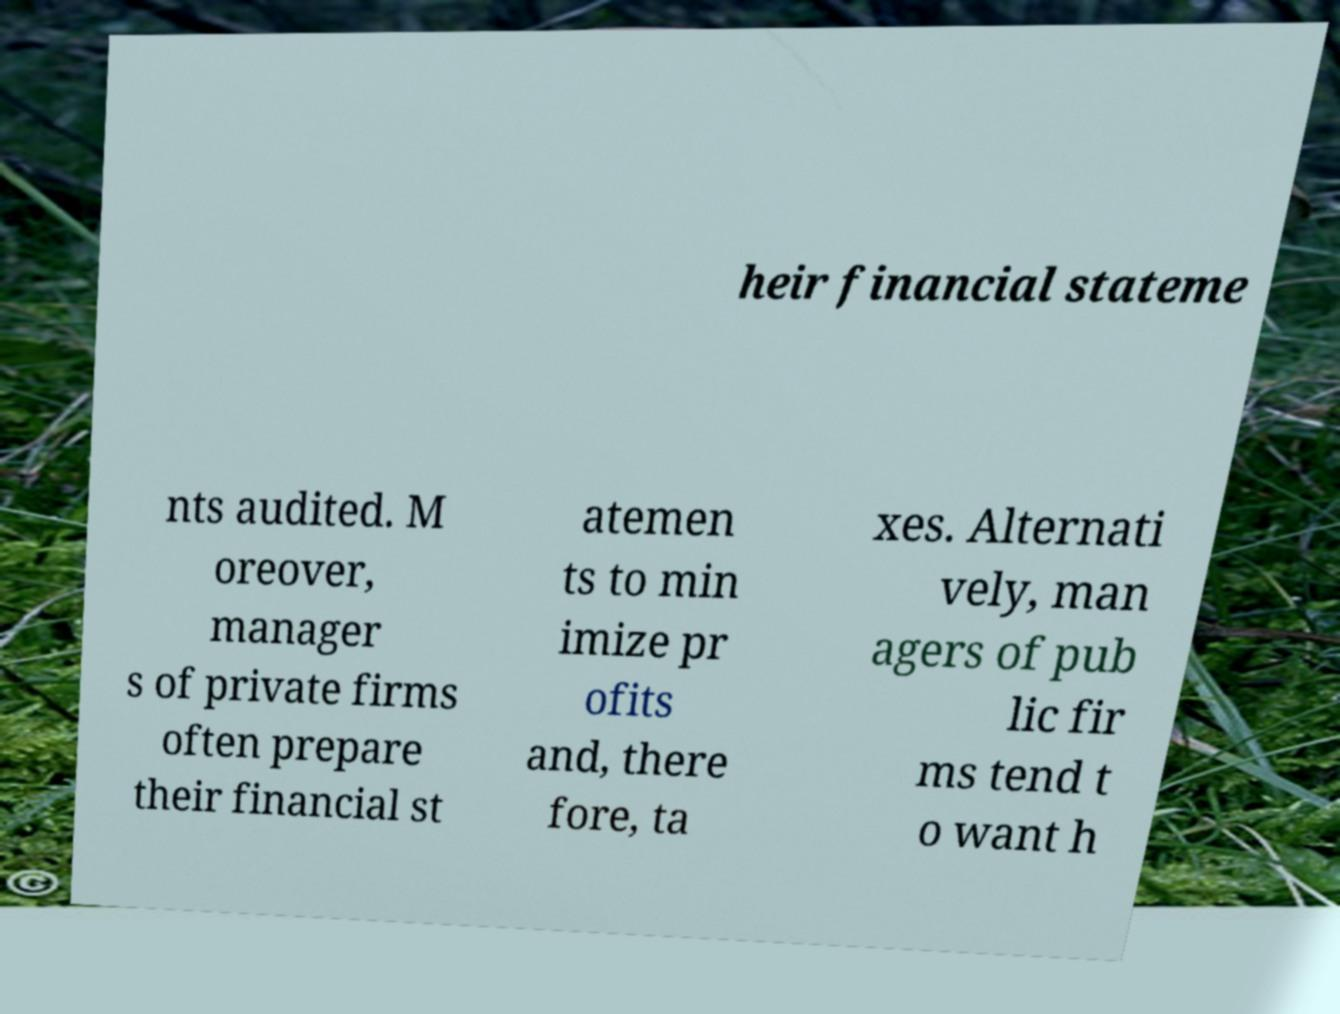Can you accurately transcribe the text from the provided image for me? heir financial stateme nts audited. M oreover, manager s of private firms often prepare their financial st atemen ts to min imize pr ofits and, there fore, ta xes. Alternati vely, man agers of pub lic fir ms tend t o want h 